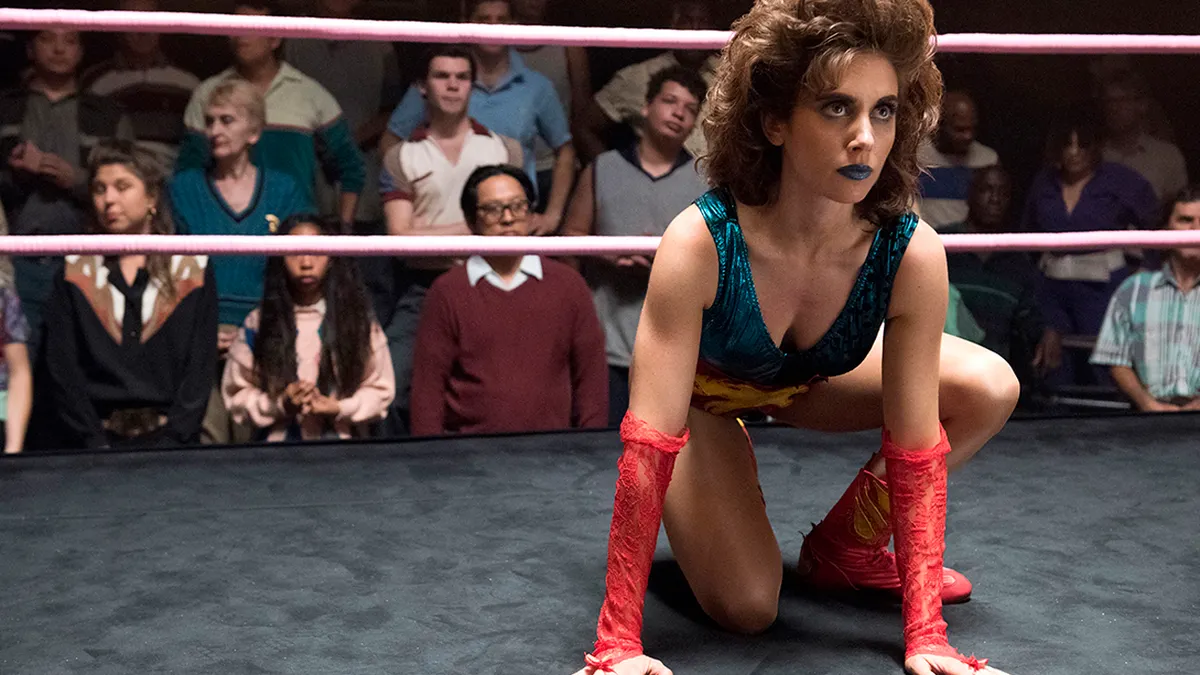What can you deduce about the character's personality based on their appearance? The character's bold, colorful costume, complete with theatrical makeup, conveys a flamboyant and confident persona, a common trait in the world of professional wrestling to captivate and entertain the audience. Their intense gaze and determined posture resonate with a strong-willed and resilient character. 